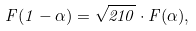<formula> <loc_0><loc_0><loc_500><loc_500>F ( 1 - \alpha ) = \sqrt { 2 1 0 } \cdot F ( \alpha ) ,</formula> 